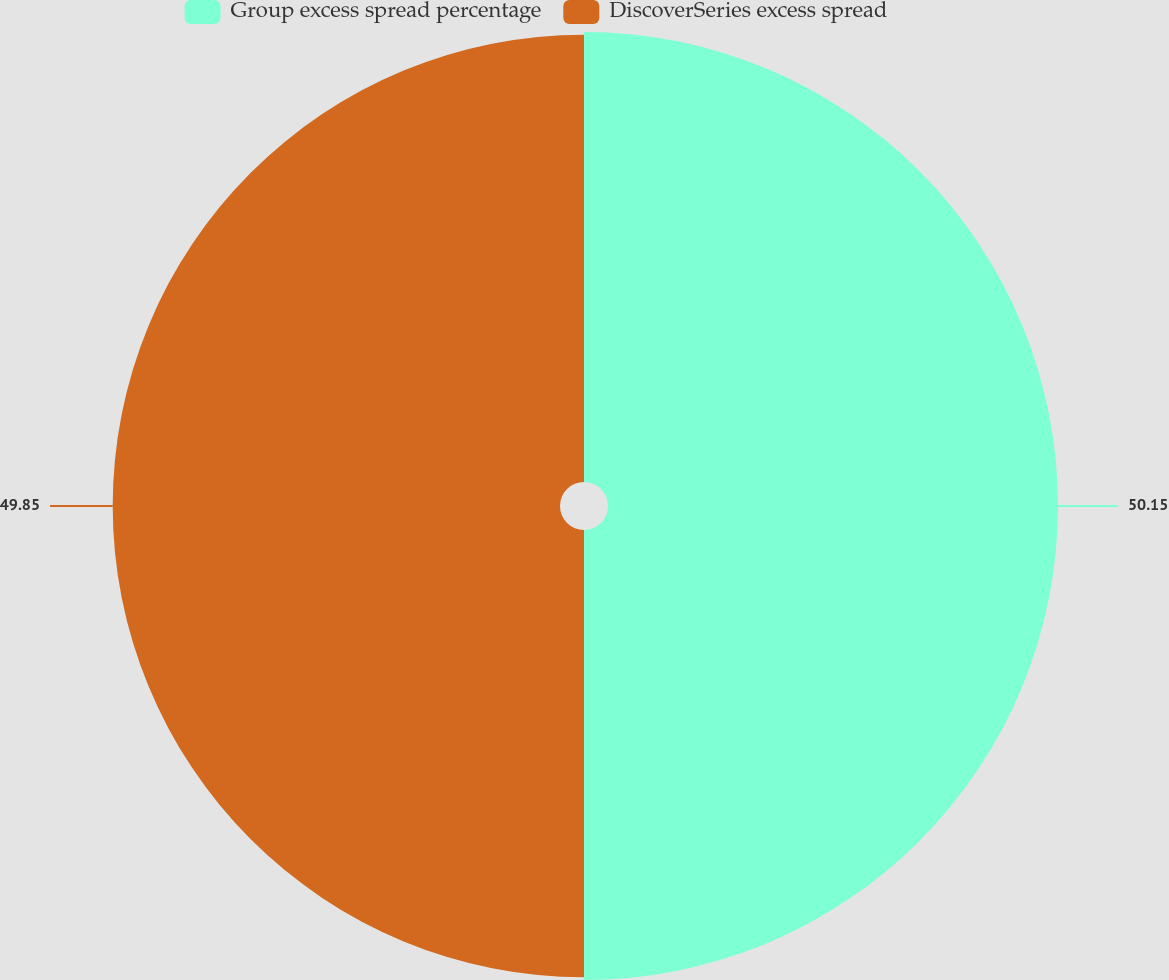Convert chart. <chart><loc_0><loc_0><loc_500><loc_500><pie_chart><fcel>Group excess spread percentage<fcel>DiscoverSeries excess spread<nl><fcel>50.15%<fcel>49.85%<nl></chart> 